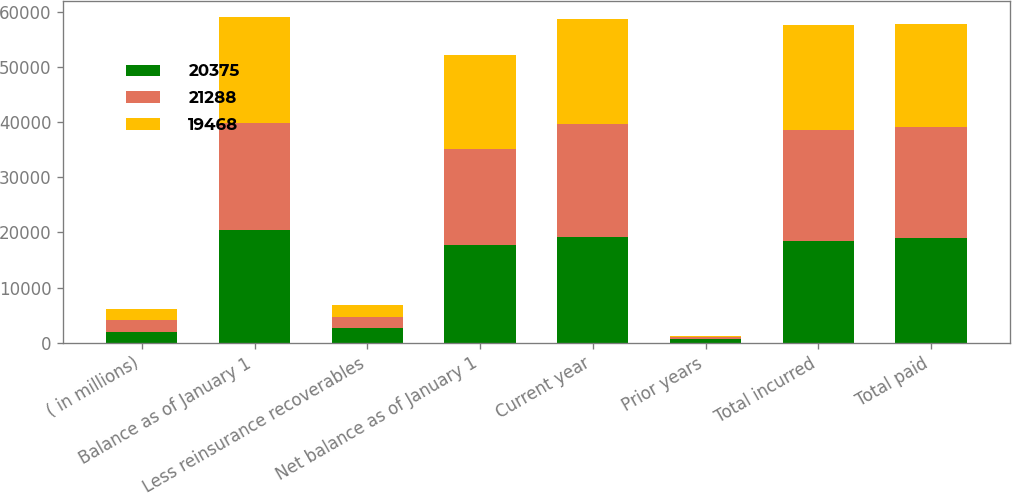<chart> <loc_0><loc_0><loc_500><loc_500><stacked_bar_chart><ecel><fcel>( in millions)<fcel>Balance as of January 1<fcel>Less reinsurance recoverables<fcel>Net balance as of January 1<fcel>Current year<fcel>Prior years<fcel>Total incurred<fcel>Total paid<nl><fcel>20375<fcel>2012<fcel>20375<fcel>2588<fcel>17787<fcel>19149<fcel>665<fcel>18484<fcel>18980<nl><fcel>21288<fcel>2011<fcel>19468<fcel>2072<fcel>17396<fcel>20496<fcel>335<fcel>20161<fcel>20195<nl><fcel>19468<fcel>2010<fcel>19167<fcel>2139<fcel>17028<fcel>19110<fcel>159<fcel>18951<fcel>18583<nl></chart> 